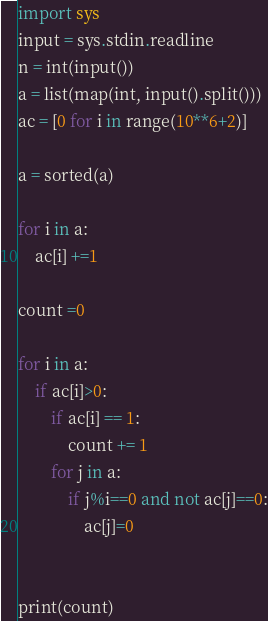Convert code to text. <code><loc_0><loc_0><loc_500><loc_500><_Python_>import sys
input = sys.stdin.readline
n = int(input())
a = list(map(int, input().split()))
ac = [0 for i in range(10**6+2)]

a = sorted(a)

for i in a:
    ac[i] +=1

count =0

for i in a:
    if ac[i]>0:
        if ac[i] == 1:
            count += 1
        for j in a:
            if j%i==0 and not ac[j]==0:
                ac[j]=0


print(count)</code> 